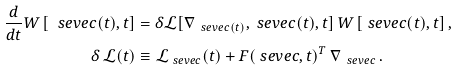<formula> <loc_0><loc_0><loc_500><loc_500>\frac { d } { d t } W \, [ \ s e v e c ( t ) , t ] & = \delta \mathcal { L } [ \nabla _ { \, \ s e v e c ( t ) } , \ s e v e c ( t ) , t ] \, W \, [ \ s e v e c ( t ) , t ] \, , \\ \delta \, \mathcal { L } ( t ) & \equiv \mathcal { L } _ { \ s e v e c } ( t ) + F ( \ s e v e c , t ) ^ { T } \, \nabla _ { \, \ s e v e c } \, .</formula> 